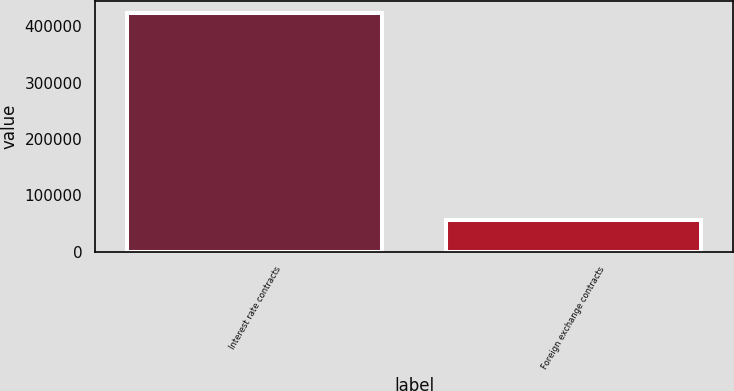<chart> <loc_0><loc_0><loc_500><loc_500><bar_chart><fcel>Interest rate contracts<fcel>Foreign exchange contracts<nl><fcel>422864<fcel>56062<nl></chart> 